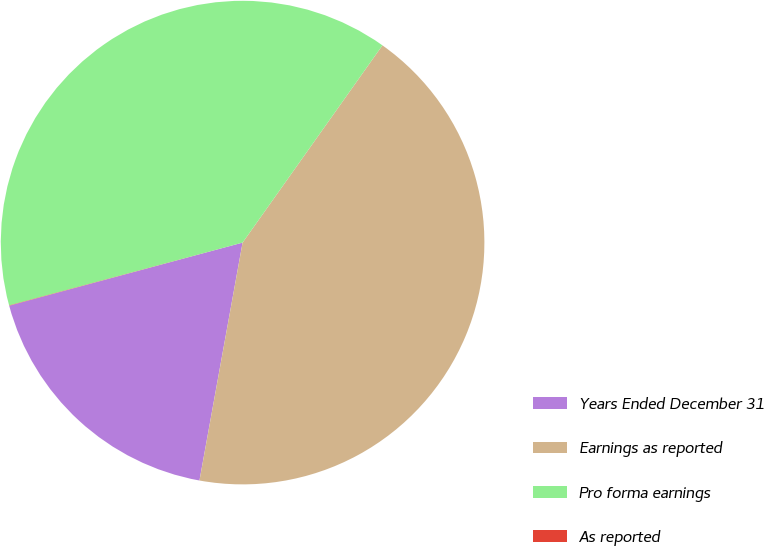Convert chart. <chart><loc_0><loc_0><loc_500><loc_500><pie_chart><fcel>Years Ended December 31<fcel>Earnings as reported<fcel>Pro forma earnings<fcel>As reported<nl><fcel>17.94%<fcel>43.04%<fcel>39.0%<fcel>0.02%<nl></chart> 